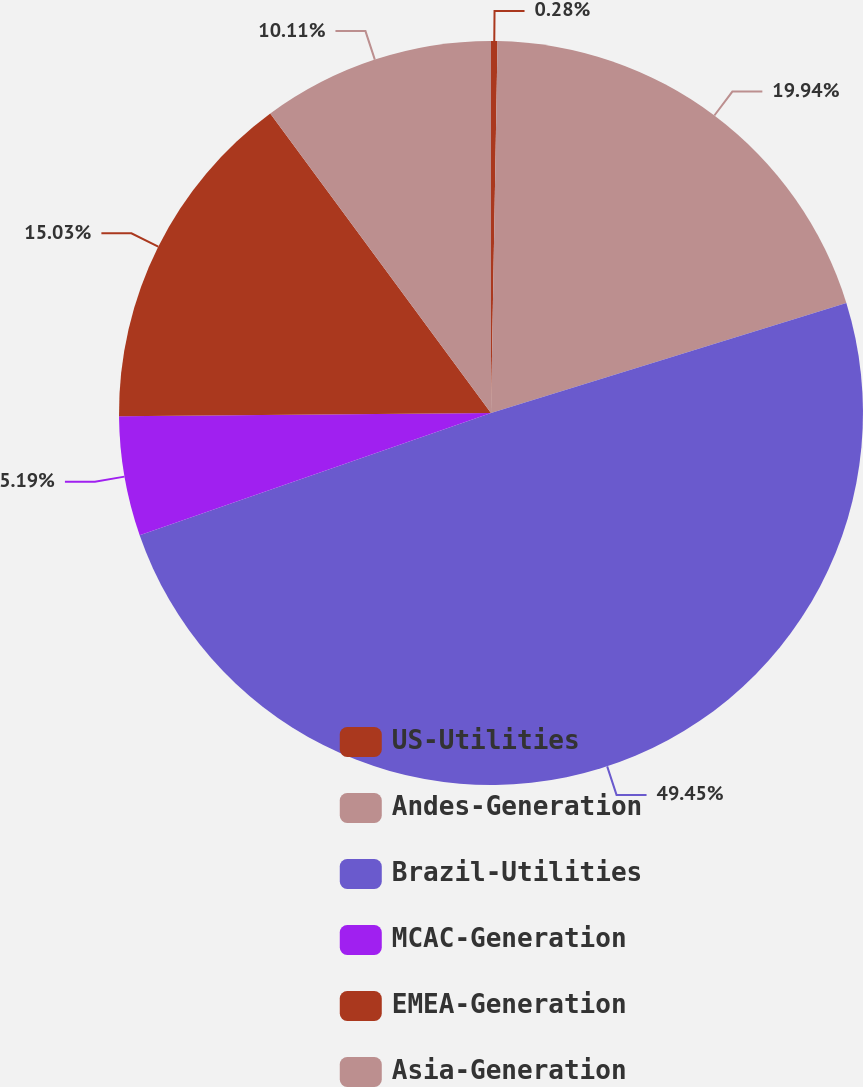Convert chart to OTSL. <chart><loc_0><loc_0><loc_500><loc_500><pie_chart><fcel>US-Utilities<fcel>Andes-Generation<fcel>Brazil-Utilities<fcel>MCAC-Generation<fcel>EMEA-Generation<fcel>Asia-Generation<nl><fcel>0.28%<fcel>19.94%<fcel>49.45%<fcel>5.19%<fcel>15.03%<fcel>10.11%<nl></chart> 